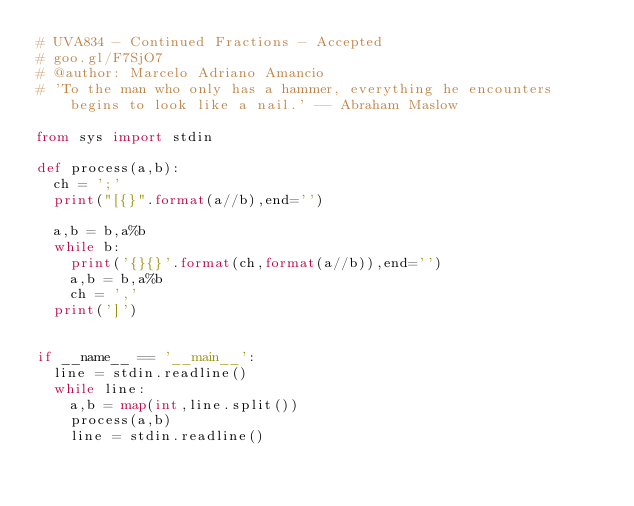Convert code to text. <code><loc_0><loc_0><loc_500><loc_500><_Python_># UVA834 - Continued Fractions - Accepted
# goo.gl/F7SjO7
# @author: Marcelo Adriano Amancio
# 'To the man who only has a hammer, everything he encounters begins to look like a nail.' -- Abraham Maslow

from sys import stdin

def process(a,b):
	ch = ';'
	print("[{}".format(a//b),end='')

	a,b = b,a%b 
	while b:
		print('{}{}'.format(ch,format(a//b)),end='')
		a,b = b,a%b
		ch = ','
	print(']')
			

if __name__ == '__main__':
	line = stdin.readline()
	while line:
		a,b = map(int,line.split())
		process(a,b)
		line = stdin.readline()
</code> 